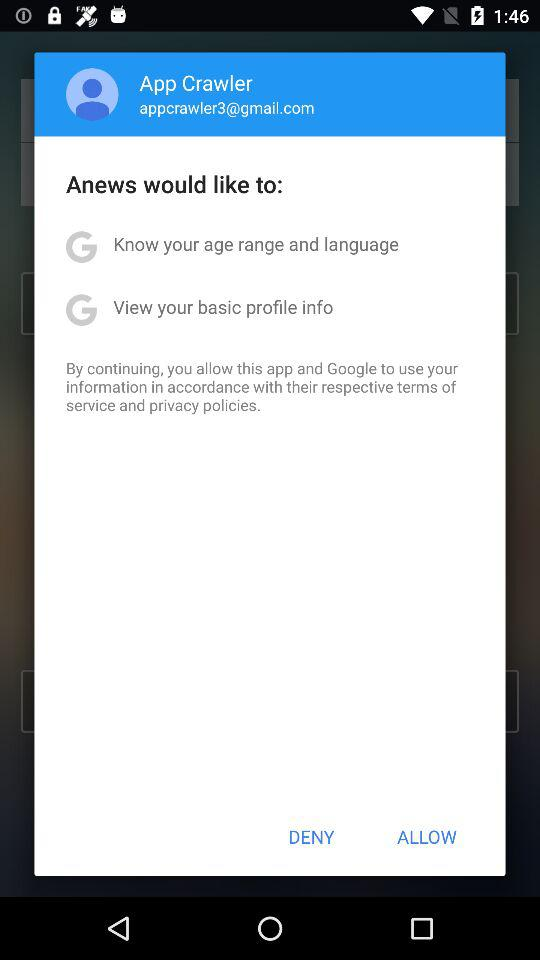What is the user name? The user name is App Crawler. 